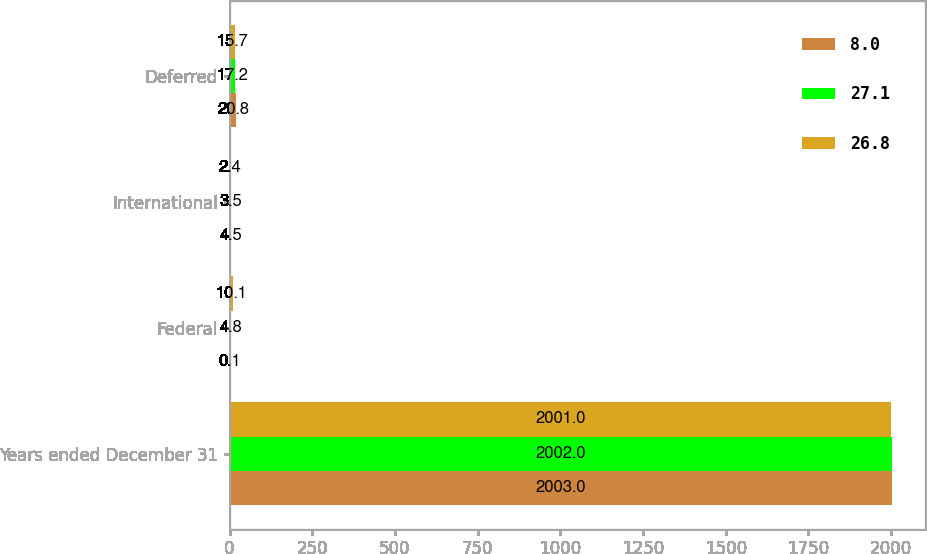Convert chart to OTSL. <chart><loc_0><loc_0><loc_500><loc_500><stacked_bar_chart><ecel><fcel>Years ended December 31<fcel>Federal<fcel>International<fcel>Deferred<nl><fcel>8<fcel>2003<fcel>0.1<fcel>4.5<fcel>20.8<nl><fcel>27.1<fcel>2002<fcel>4.8<fcel>3.5<fcel>17.2<nl><fcel>26.8<fcel>2001<fcel>10.1<fcel>2.4<fcel>15.7<nl></chart> 